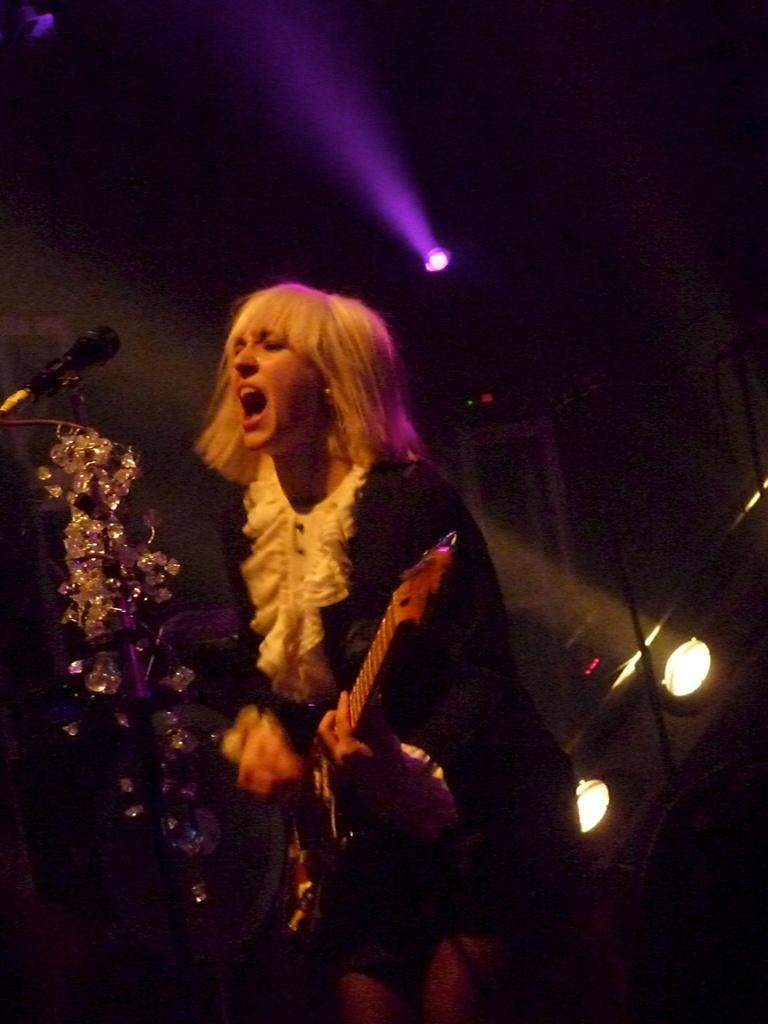Who is the main subject in the image? There is a woman in the image. What is the woman doing in the image? The woman is singing and playing a guitar. What tool is the woman using to amplify her voice? The woman is using a microphone. What can be seen in the background of the image? There are lights visible in the image. Where is the school located in the image? There is no school present in the image. What type of store can be seen in the background of the image? There is no store visible in the image. 